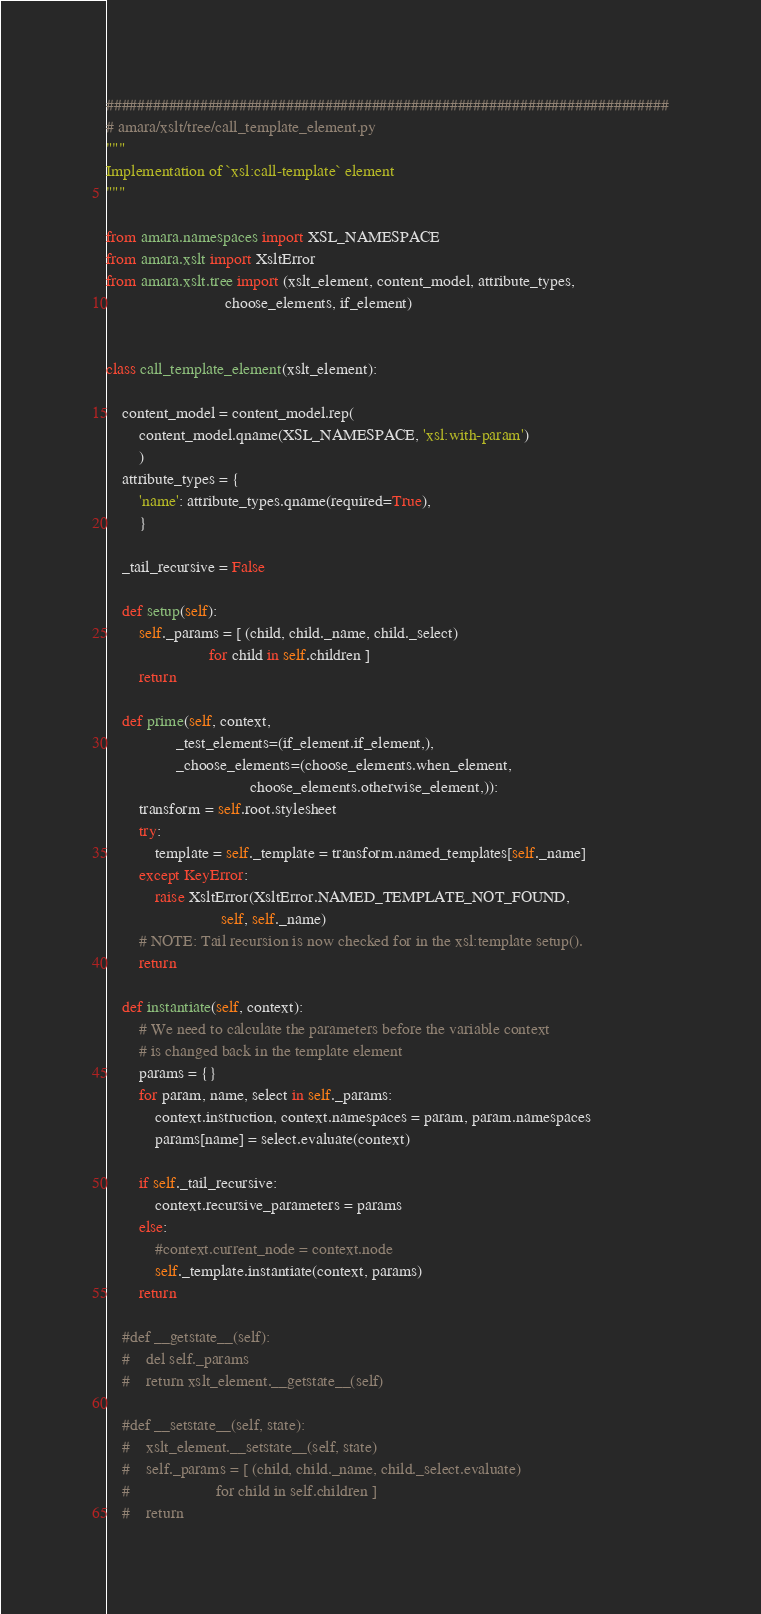Convert code to text. <code><loc_0><loc_0><loc_500><loc_500><_Python_>########################################################################
# amara/xslt/tree/call_template_element.py
"""
Implementation of `xsl:call-template` element
"""

from amara.namespaces import XSL_NAMESPACE
from amara.xslt import XsltError
from amara.xslt.tree import (xslt_element, content_model, attribute_types,
                             choose_elements, if_element)


class call_template_element(xslt_element):

    content_model = content_model.rep(
        content_model.qname(XSL_NAMESPACE, 'xsl:with-param')
        )
    attribute_types = {
        'name': attribute_types.qname(required=True),
        }

    _tail_recursive = False

    def setup(self):
        self._params = [ (child, child._name, child._select)
                         for child in self.children ]
        return

    def prime(self, context,
                 _test_elements=(if_element.if_element,),
                 _choose_elements=(choose_elements.when_element,
                                   choose_elements.otherwise_element,)):
        transform = self.root.stylesheet
        try:
            template = self._template = transform.named_templates[self._name]
        except KeyError:
            raise XsltError(XsltError.NAMED_TEMPLATE_NOT_FOUND,
                            self, self._name)
        # NOTE: Tail recursion is now checked for in the xsl:template setup().
        return

    def instantiate(self, context):
        # We need to calculate the parameters before the variable context
        # is changed back in the template element
        params = {}
        for param, name, select in self._params:
            context.instruction, context.namespaces = param, param.namespaces
            params[name] = select.evaluate(context)

        if self._tail_recursive:
            context.recursive_parameters = params
        else:
            #context.current_node = context.node
            self._template.instantiate(context, params)
        return

    #def __getstate__(self):
    #    del self._params
    #    return xslt_element.__getstate__(self)

    #def __setstate__(self, state):
    #    xslt_element.__setstate__(self, state)
    #    self._params = [ (child, child._name, child._select.evaluate)
    #                     for child in self.children ]
    #    return
</code> 